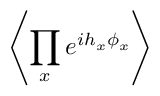Convert formula to latex. <formula><loc_0><loc_0><loc_500><loc_500>\left \langle \prod _ { x } e ^ { i h _ { x } \phi _ { x } } \right \rangle</formula> 